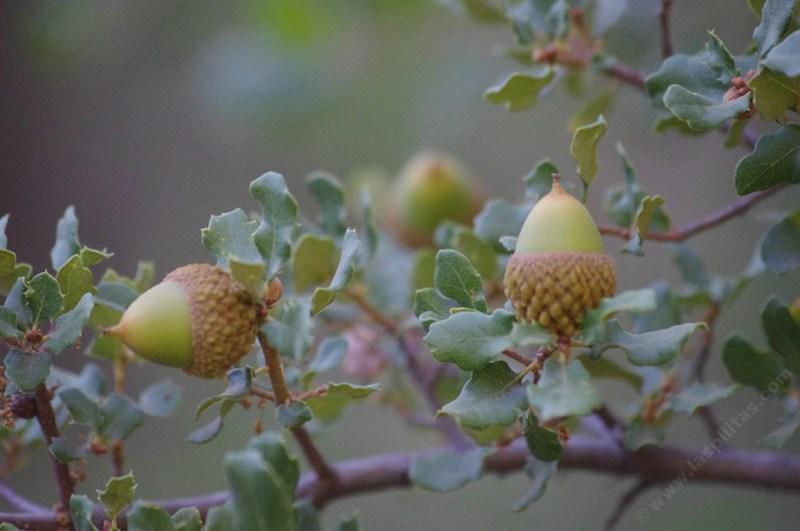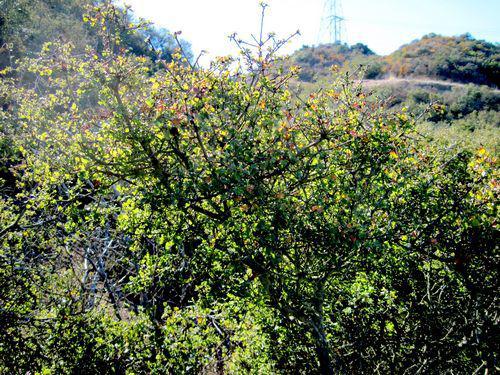The first image is the image on the left, the second image is the image on the right. Examine the images to the left and right. Is the description "The left image shows two green acorns in the foreground which lack any brown patches on their skins, and the right image shows foliage without individually distinguishable acorns." accurate? Answer yes or no. Yes. The first image is the image on the left, the second image is the image on the right. For the images displayed, is the sentence "One of the images is an acorn close up and the other only shows branches and leaves." factually correct? Answer yes or no. Yes. 